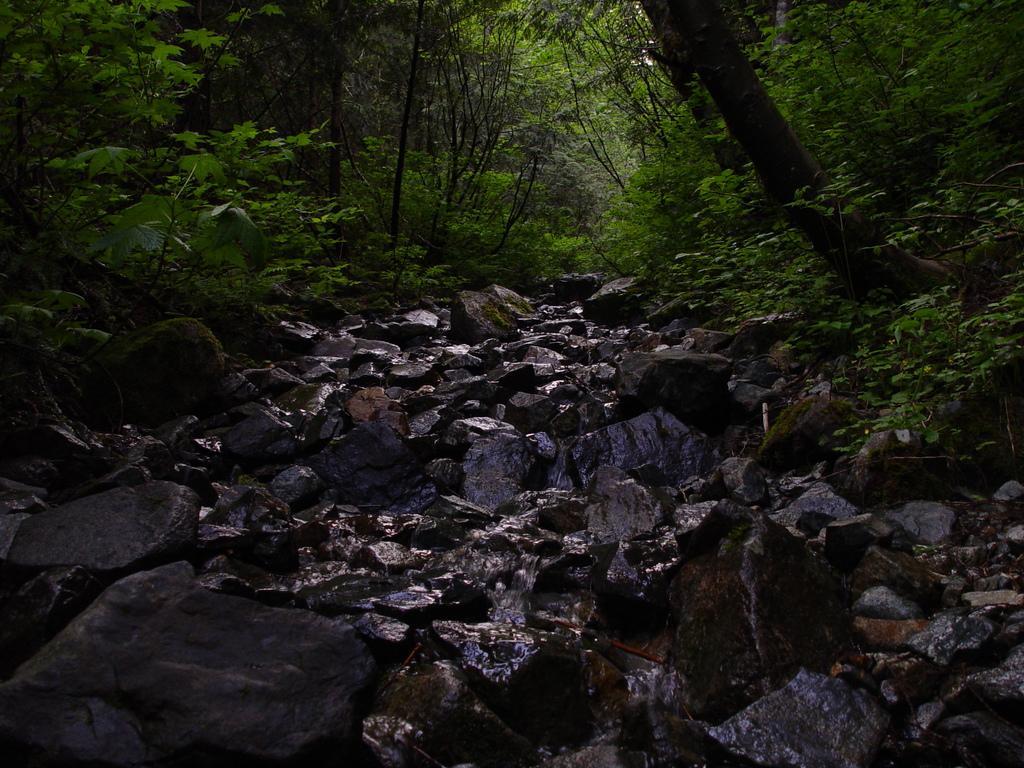How would you summarize this image in a sentence or two? In the foreground of the picture there are plants and stones. In the background we can see trees and plants. The picture might be taken in a forest. 